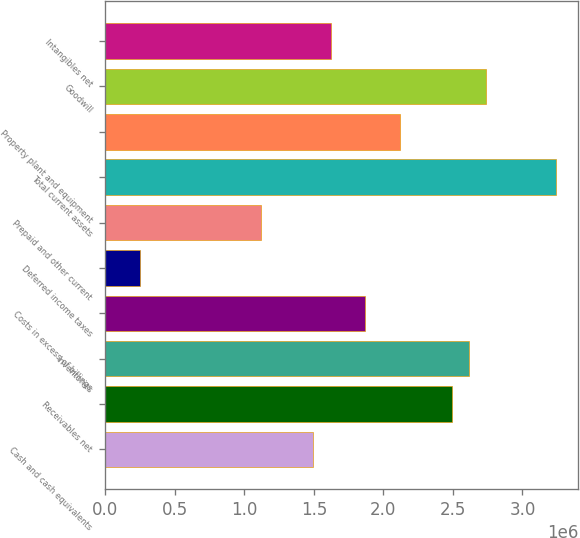Convert chart. <chart><loc_0><loc_0><loc_500><loc_500><bar_chart><fcel>Cash and cash equivalents<fcel>Receivables net<fcel>Inventories<fcel>Costs in excess of billings<fcel>Deferred income taxes<fcel>Prepaid and other current<fcel>Total current assets<fcel>Property plant and equipment<fcel>Goodwill<fcel>Intangibles net<nl><fcel>1.49551e+06<fcel>2.49195e+06<fcel>2.6165e+06<fcel>1.86917e+06<fcel>249961<fcel>1.12185e+06<fcel>3.23928e+06<fcel>2.11828e+06<fcel>2.74106e+06<fcel>1.62006e+06<nl></chart> 